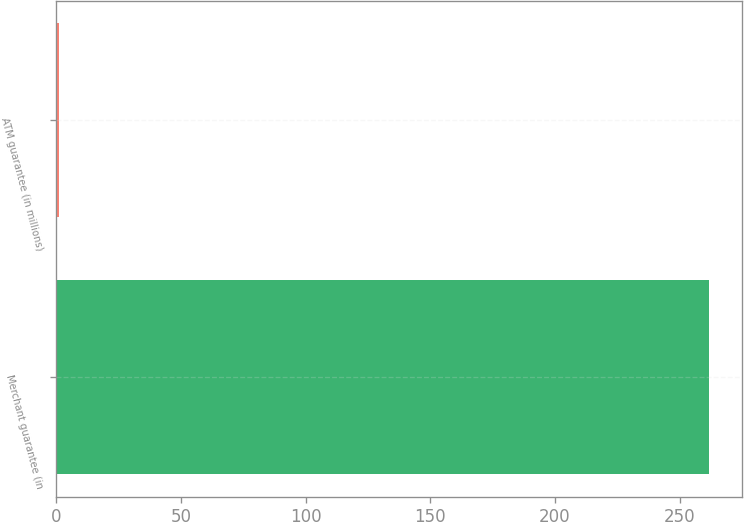Convert chart. <chart><loc_0><loc_0><loc_500><loc_500><bar_chart><fcel>Merchant guarantee (in<fcel>ATM guarantee (in millions)<nl><fcel>262<fcel>1<nl></chart> 